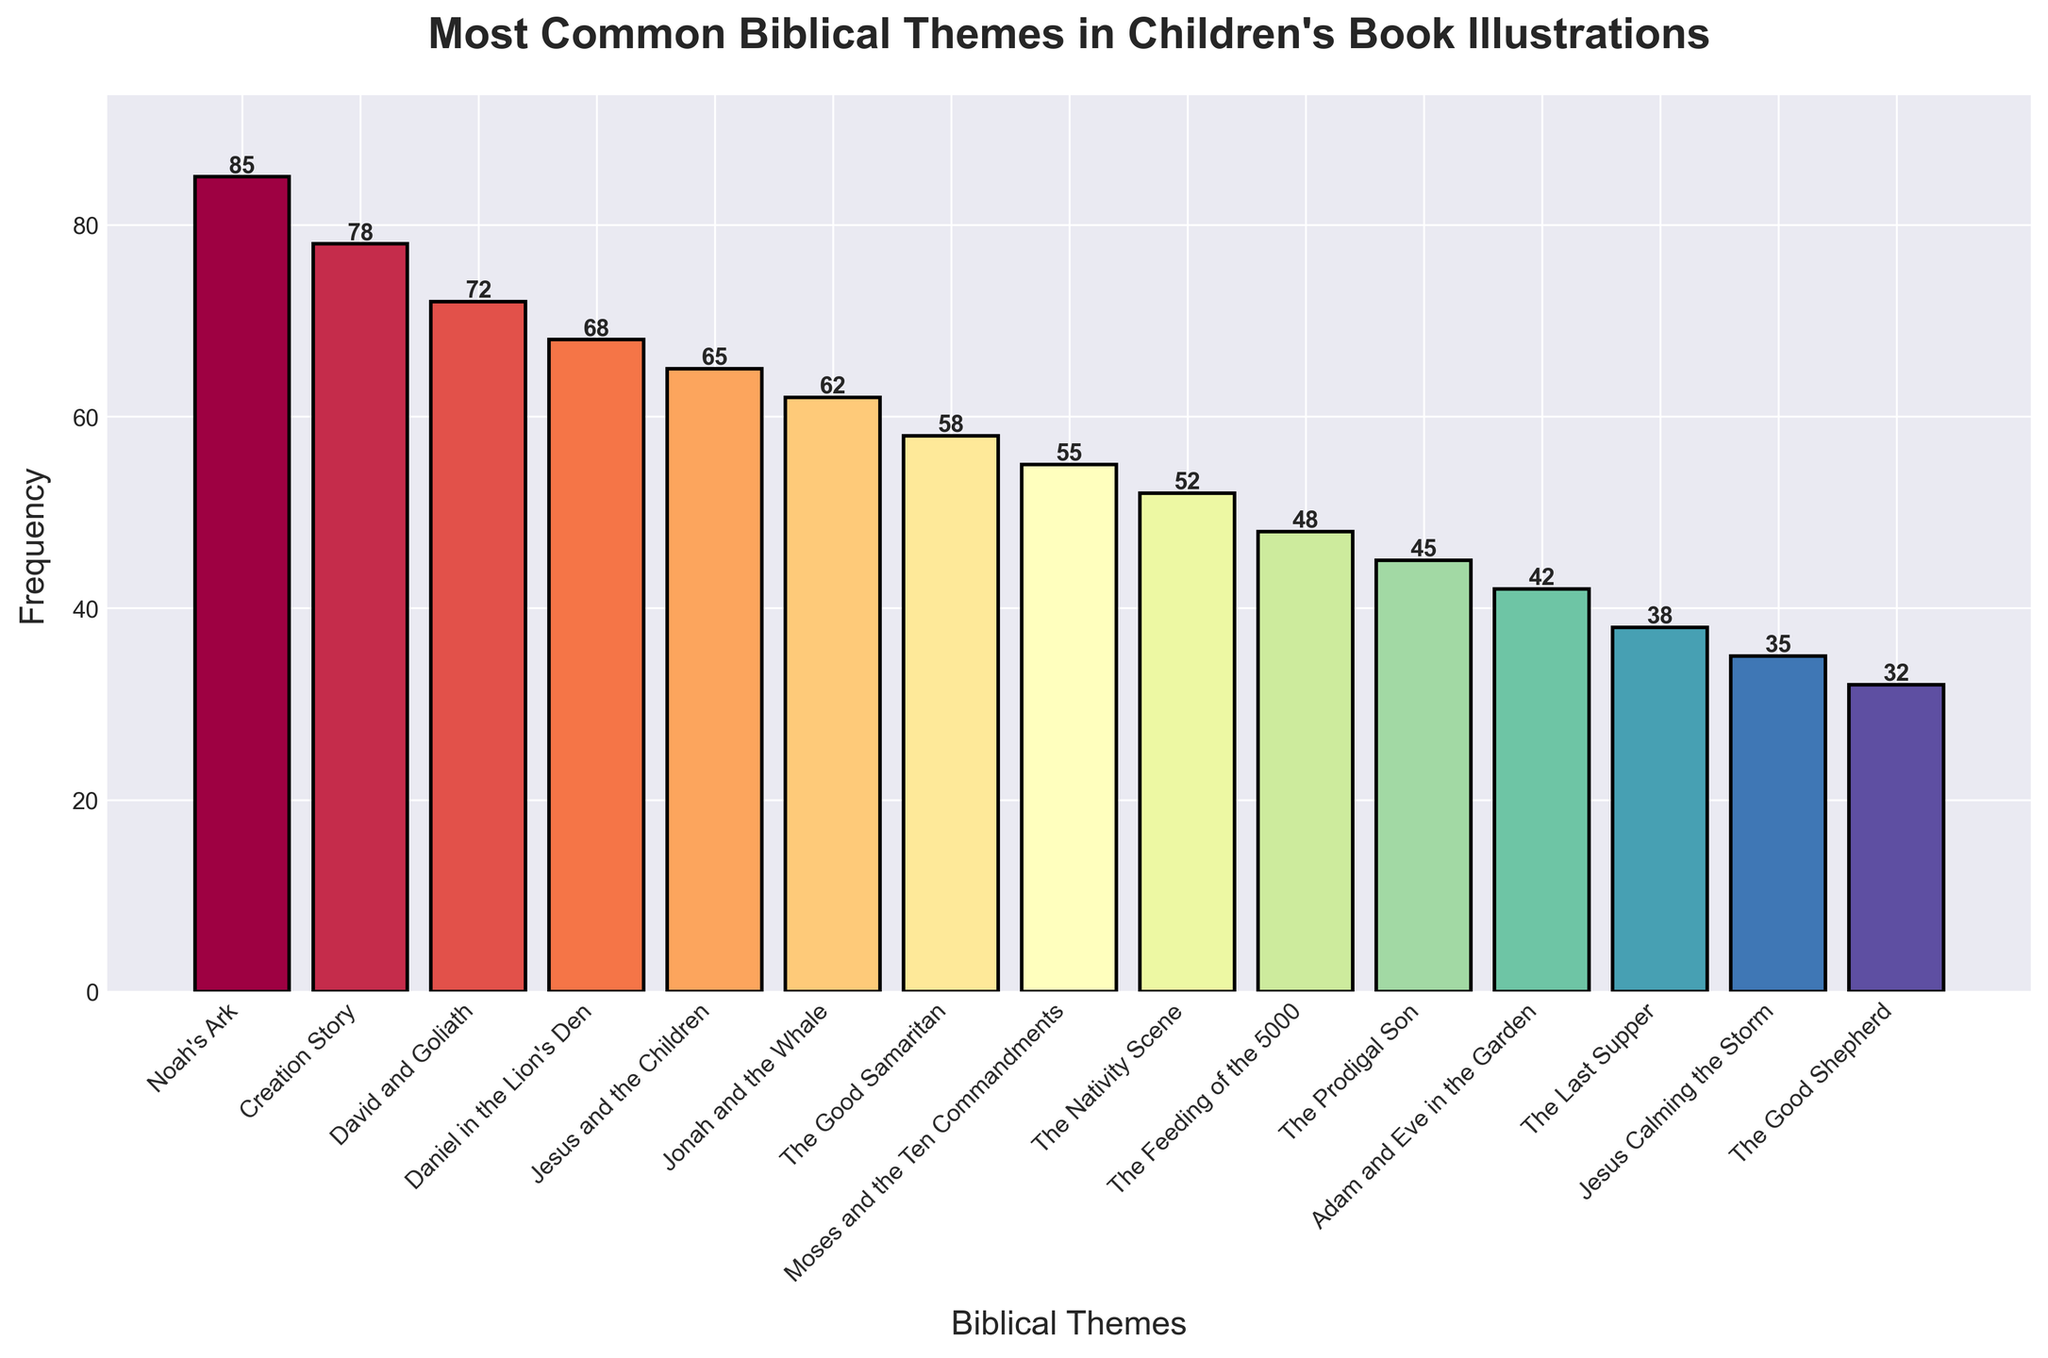Which biblical theme has the highest frequency in the chart? The bar for "Noah's Ark" reaches the highest point on the chart, exceeding all other themes.
Answer: Noah's Ark What is the difference in frequency between "David and Goliath" and "The Good Samaritan"? "David and Goliath" has a frequency of 72, while "The Good Samaritan" has a frequency of 58. Subtracting these two gives 72 - 58 = 14.
Answer: 14 Which theme has a higher frequency: "Daniel in the Lion's Den" or "Jesus and the Children"? "Daniel in the Lion's Den" has a frequency of 68 and "Jesus and the Children" has a frequency of 65. Comparing these, 68 is greater than 65.
Answer: Daniel in the Lion's Den How many themes have a frequency greater than 60? The themes "Noah's Ark" (85), "Creation Story" (78), "David and Goliath" (72), "Daniel in the Lion's Den" (68), "Jesus and the Children" (65), and "Jonah and the Whale" (62) all have frequencies greater than 60, resulting in 6 themes.
Answer: 6 What's the average frequency of the top three most common themes? The top three themes are "Noah's Ark" (85), "Creation Story" (78), and "David and Goliath" (72). Summing these gives 85 + 78 + 72 = 235. Dividing by 3 yields an average of 235 / 3 ≈ 78.33.
Answer: 78.33 Are there more themes with a frequency above 50 or below 50? Themes above 50: Noah's Ark, Creation Story, David and Goliath, Daniel in the Lion's Den, Jesus and the Children, Jonah and the Whale, The Good Samaritan, Moses and the Ten Commandments, The Nativity Scene (9 themes). Themes below 50: The Feeding of the 5000, The Prodigal Son, Adam and Eve in the Garden, The Last Supper, Jesus Calming the Storm, The Good Shepherd (6 themes).
Answer: Above 50 What is the total frequency of the three least common themes? The three least common themes are "Jesus Calming the Storm" (35), "The Good Shepherd" (32), and "The Last Supper" (38). Summing these gives 35 + 32 + 38 = 105.
Answer: 105 Which theme represented by a bar with a middle-range frequency (somewhere between highest and lowest values) appears to be thickest in the chart? Visually, the bar for "Jonah and the Whale," with a frequency of 62, appears to be of similar thickness to others but is highlighted distinctly within the middle range frequencies.
Answer: Jonah and the Whale 